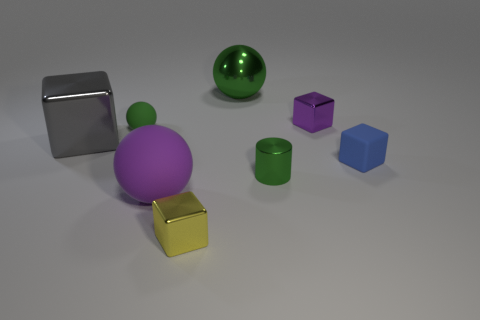Subtract all tiny cubes. How many cubes are left? 1 Add 2 tiny gray metal spheres. How many objects exist? 10 Subtract all red cubes. Subtract all blue cylinders. How many cubes are left? 4 Subtract all cylinders. How many objects are left? 7 Subtract all large purple rubber balls. Subtract all green rubber balls. How many objects are left? 6 Add 6 tiny green balls. How many tiny green balls are left? 7 Add 1 small cyan metal spheres. How many small cyan metal spheres exist? 1 Subtract 0 blue spheres. How many objects are left? 8 